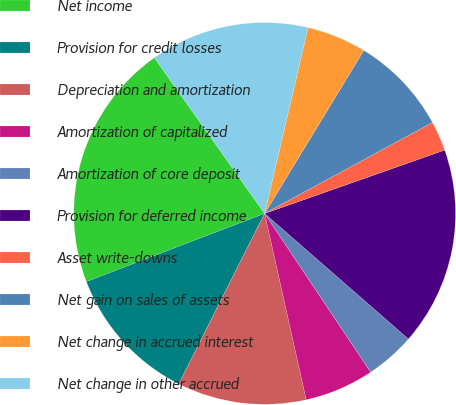Convert chart. <chart><loc_0><loc_0><loc_500><loc_500><pie_chart><fcel>Net income<fcel>Provision for credit losses<fcel>Depreciation and amortization<fcel>Amortization of capitalized<fcel>Amortization of core deposit<fcel>Provision for deferred income<fcel>Asset write-downs<fcel>Net gain on sales of assets<fcel>Net change in accrued interest<fcel>Net change in other accrued<nl><fcel>21.01%<fcel>11.76%<fcel>10.92%<fcel>5.88%<fcel>4.2%<fcel>16.81%<fcel>2.52%<fcel>8.4%<fcel>5.04%<fcel>13.45%<nl></chart> 